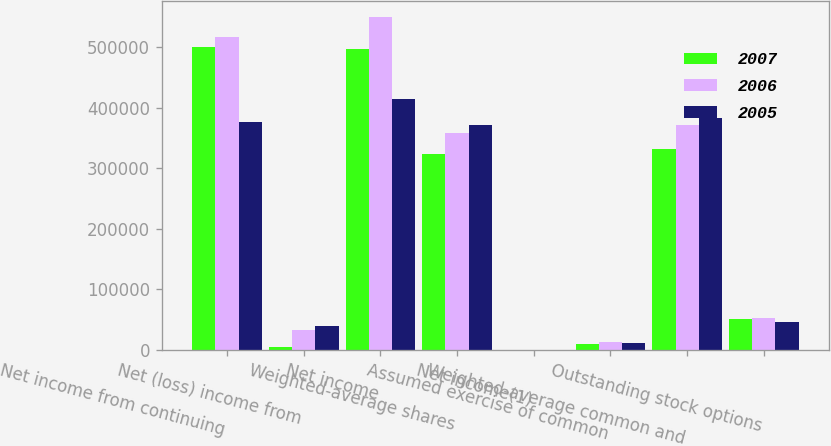Convert chart to OTSL. <chart><loc_0><loc_0><loc_500><loc_500><stacked_bar_chart><ecel><fcel>Net income from continuing<fcel>Net (loss) income from<fcel>Net income<fcel>Weighted-average shares<fcel>Net income(1)<fcel>Assumed exercise of common<fcel>Weighted-average common and<fcel>Outstanding stock options<nl><fcel>2007<fcel>500695<fcel>3788<fcel>496907<fcel>323255<fcel>1.54<fcel>9046<fcel>332301<fcel>49915<nl><fcel>2006<fcel>516314<fcel>33168<fcel>549482<fcel>358762<fcel>1.53<fcel>12202<fcel>370964<fcel>52054<nl><fcel>2005<fcel>375944<fcel>38843<fcel>414787<fcel>371791<fcel>1.12<fcel>11683<fcel>383474<fcel>46452<nl></chart> 